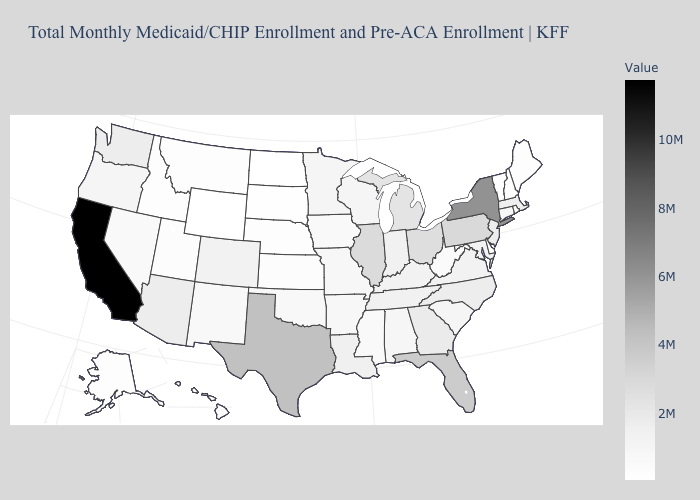Does Vermont have the lowest value in the Northeast?
Give a very brief answer. Yes. Does Texas have the highest value in the South?
Keep it brief. Yes. Does Virginia have the highest value in the USA?
Be succinct. No. Among the states that border Oregon , which have the lowest value?
Give a very brief answer. Idaho. Which states have the highest value in the USA?
Keep it brief. California. Which states have the lowest value in the Northeast?
Answer briefly. Vermont. 